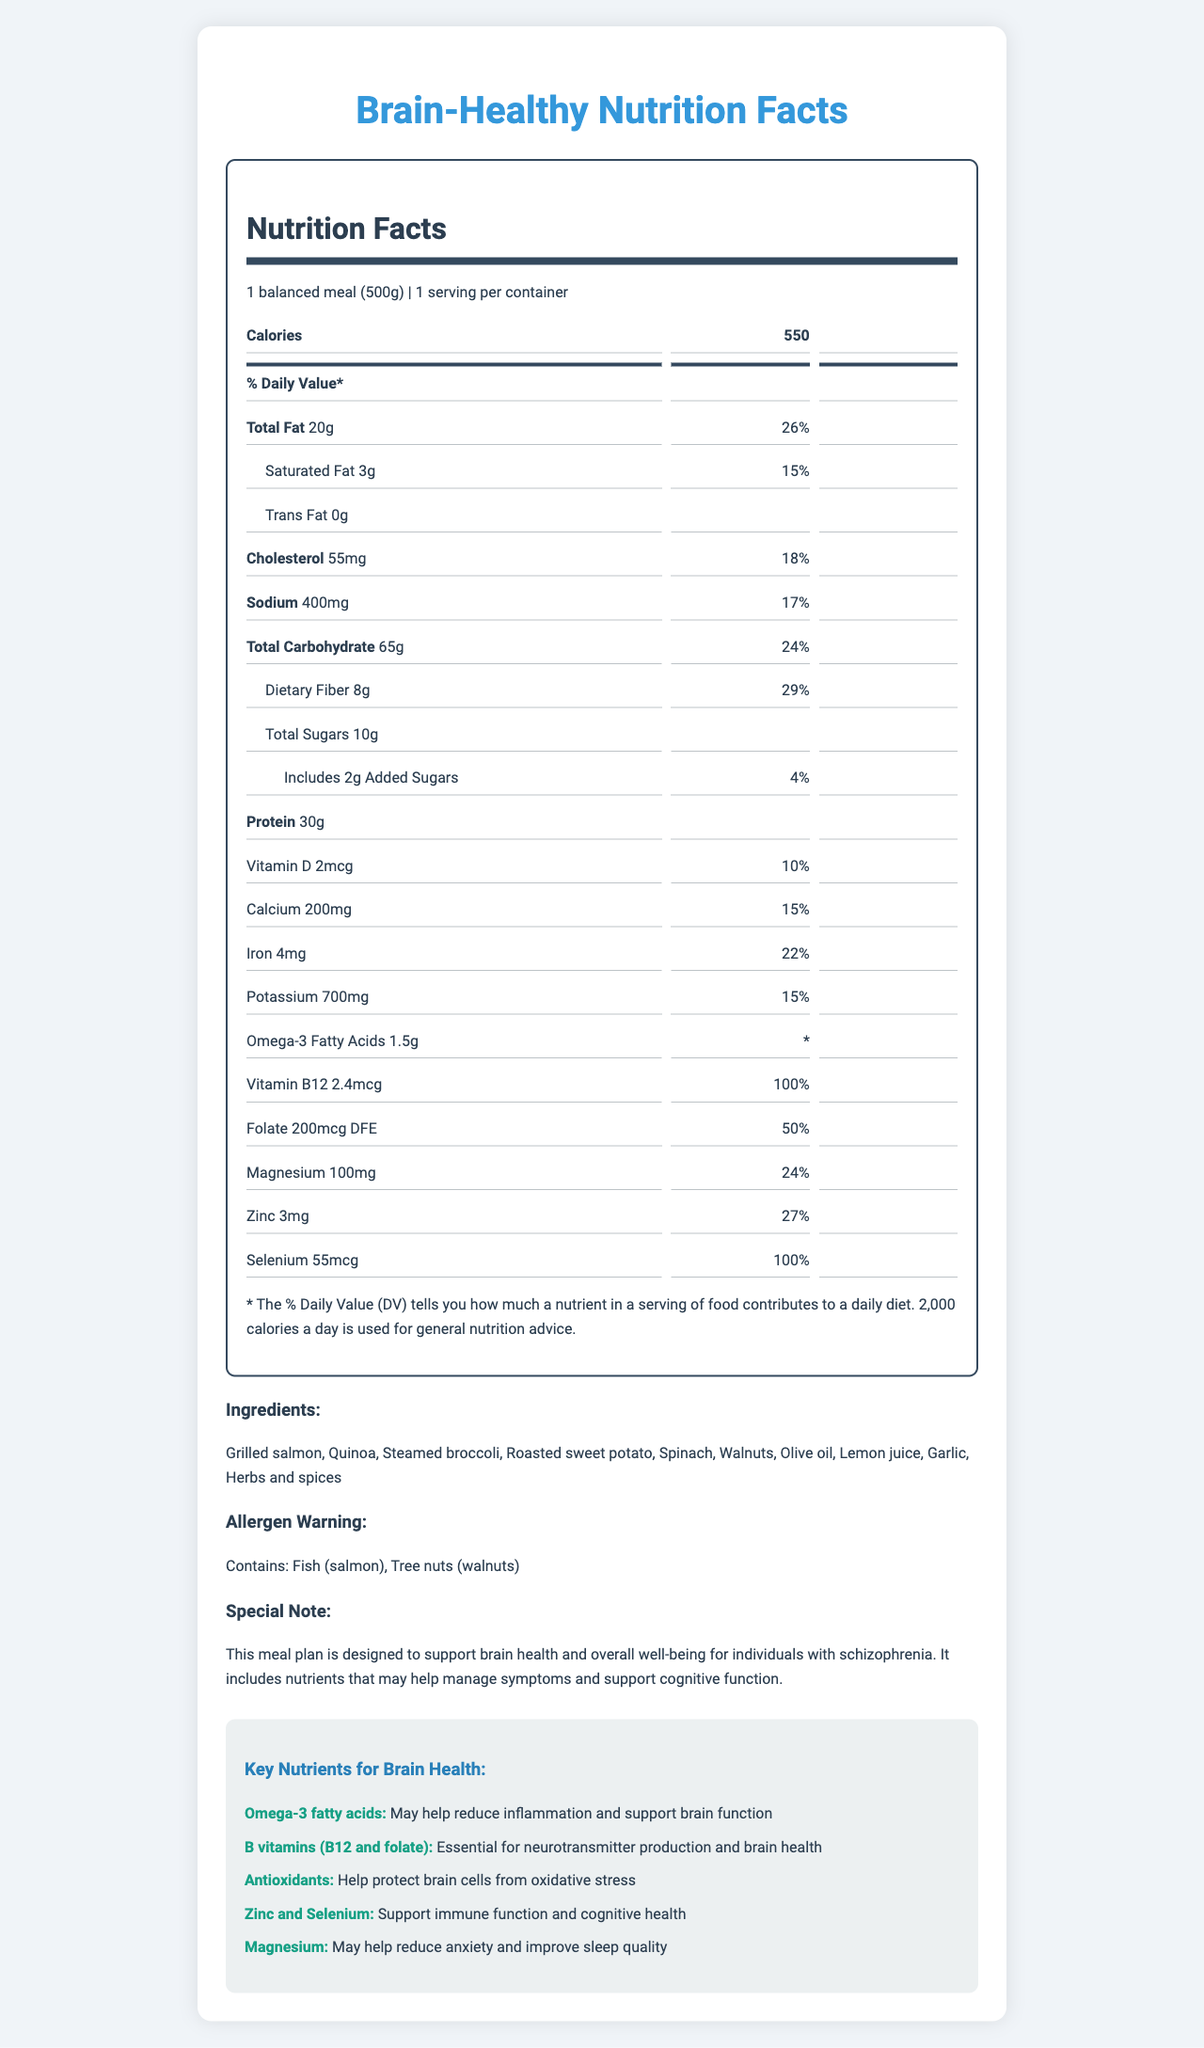what is the serving size for this meal plan? The serving size information is given at the top of the Nutrition Facts Label, stating "1 balanced meal (500g)".
Answer: 1 balanced meal (500g) how many calories are in a single serving of this meal? The label lists "Calories" as 550 for one serving, which is the entire balanced meal.
Answer: 550 what are the two main allergens mentioned on the label? Under "Allergen Warning," the document specifies that the meal contains Fish (salmon) and Tree nuts (walnuts).
Answer: Fish (salmon), Tree nuts (walnuts) what is the amount of dietary fiber in this meal? The amount of dietary fiber is listed under Total Carbohydrate as "Dietary Fiber 8g".
Answer: 8g how much protein does this meal provide? The amount of protein is listed towards the bottom of the Nutrition Facts as "Protein 30g".
Answer: 30g which nutrient is present in the highest amount per serving (percentage daily value)? A. Cholesterol B. Vitamin B12 C. Folate The daily value for Vitamin B12 is 100%, which is the highest percentage listed on the label.
Answer: B. Vitamin B12 which ingredient is not part of the meal? A. Quinoa B. Chicken C. Spinach The ingredients listed are "Grilled salmon, Quinoa, Steamed broccoli, Roasted sweet potato, Spinach, Walnuts, Olive oil, Lemon juice, Garlic, Herbs and spices," and chicken is not included.
Answer: B. Chicken is there any trans fat in this meal? The label specifically lists "Trans Fat 0g," indicating there is no trans fat.
Answer: No what is the main purpose of this meal plan as stated in the document? The special note at the bottom of the document states that the meal plan is designed to support brain health and overall well-being for individuals with schizophrenia.
Answer: To support brain health and overall well-being for individuals with schizophrenia does this meal contribute a significant amount of omega-3 fatty acids? The meal provides 1.5g of omega-3 fatty acids, which is significant for supporting brain function.
Answer: Yes describe the main idea of the document. The document is a Nutrition Facts Label that includes information about calories, macronutrients, micronutrients, ingredients, allergens, and special notes aimed at supporting individuals with schizophrenia.
Answer: The document provides nutrition details for a balanced meal plan designed for individuals with schizophrenia. It lists the serving size, nutritional content, ingredients, allergen warning, and key nutrients specifically beneficial for brain health and managing schizophrenia symptoms. what is the total amount of calcium in this meal? The amount of calcium in the meal is listed as "Calcium 200mg".
Answer: 200mg is the daily value percentage for magnesium higher or lower than that for dietary fiber? The daily value for Magnesium is 24%, while for Dietary Fiber it is 29%.
Answer: Lower can this meal help in reducing inflammation? The document mentions that one of the key nutrients, Omega-3 fatty acids, may help reduce inflammation to support brain function.
Answer: Yes can the exact benefits of antioxidants be determined from the document? Antioxidants help protect brain cells from oxidative stress, as noted under the key nutrients section.
Answer: Yes what are the possible cognitive benefits of zinc and selenium in the meal? The key nutrients section lists zinc and selenium as beneficial for immune function and cognitive health.
Answer: Support immune function and cognitive health what percentage of the daily value for potassium does this meal provide? The label shows that the meal provides 700mg of potassium, which is equal to 15% of the daily value.
Answer: 15% what is the main source of protein in this meal? Among the ingredients listed, grilled salmon is the primary source of protein.
Answer: Grilled salmon what is the purpose of folate in the meal plan? The key nutrients section mentions that folate is essential for neurotransmitter production and brain health.
Answer: Essential for neurotransmitter production and brain health what is the amount of added sugars in this meal? The amount of added sugars is listed under Total Sugars as "Includes 2g Added Sugars".
Answer: 2g 